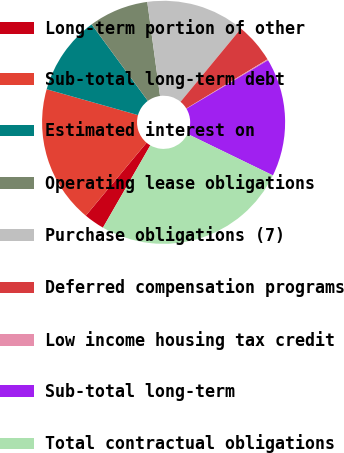Convert chart. <chart><loc_0><loc_0><loc_500><loc_500><pie_chart><fcel>Long-term portion of other<fcel>Sub-total long-term debt<fcel>Estimated interest on<fcel>Operating lease obligations<fcel>Purchase obligations (7)<fcel>Deferred compensation programs<fcel>Low income housing tax credit<fcel>Sub-total long-term<fcel>Total contractual obligations<nl><fcel>2.74%<fcel>18.33%<fcel>10.53%<fcel>7.94%<fcel>13.13%<fcel>5.34%<fcel>0.14%<fcel>15.73%<fcel>26.12%<nl></chart> 